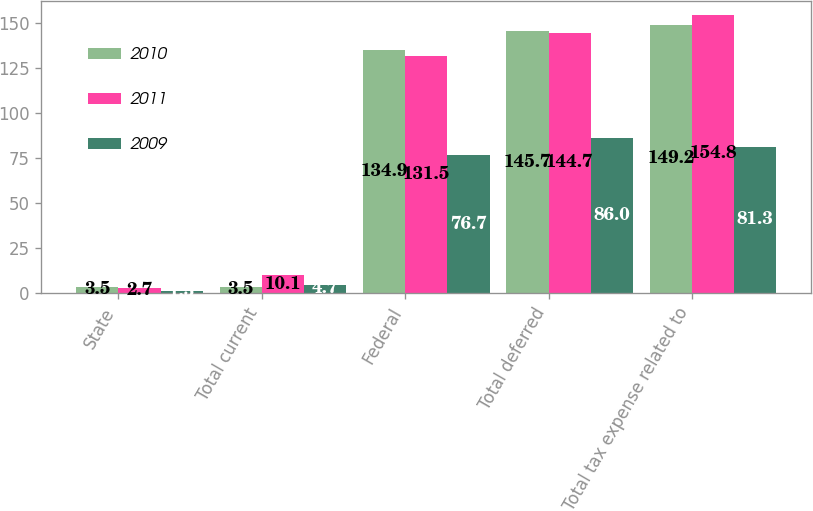Convert chart. <chart><loc_0><loc_0><loc_500><loc_500><stacked_bar_chart><ecel><fcel>State<fcel>Total current<fcel>Federal<fcel>Total deferred<fcel>Total tax expense related to<nl><fcel>2010<fcel>3.5<fcel>3.5<fcel>134.9<fcel>145.7<fcel>149.2<nl><fcel>2011<fcel>2.7<fcel>10.1<fcel>131.5<fcel>144.7<fcel>154.8<nl><fcel>2009<fcel>1.3<fcel>4.7<fcel>76.7<fcel>86<fcel>81.3<nl></chart> 